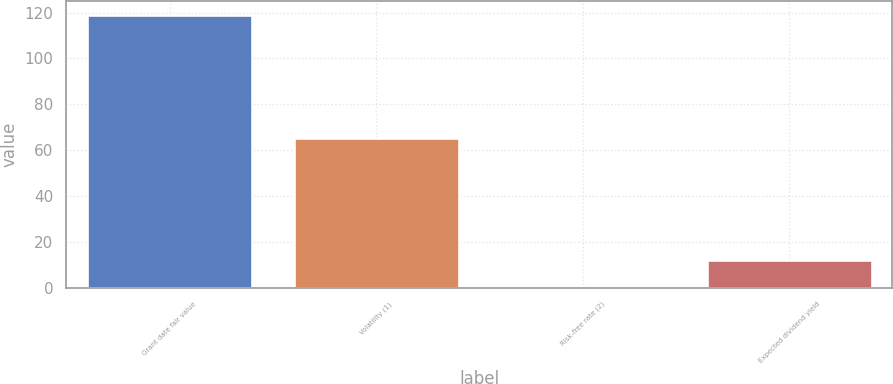Convert chart. <chart><loc_0><loc_0><loc_500><loc_500><bar_chart><fcel>Grant date fair value<fcel>Volatility (1)<fcel>Risk-free rate (2)<fcel>Expected dividend yield<nl><fcel>119<fcel>65.5<fcel>0.18<fcel>12.06<nl></chart> 